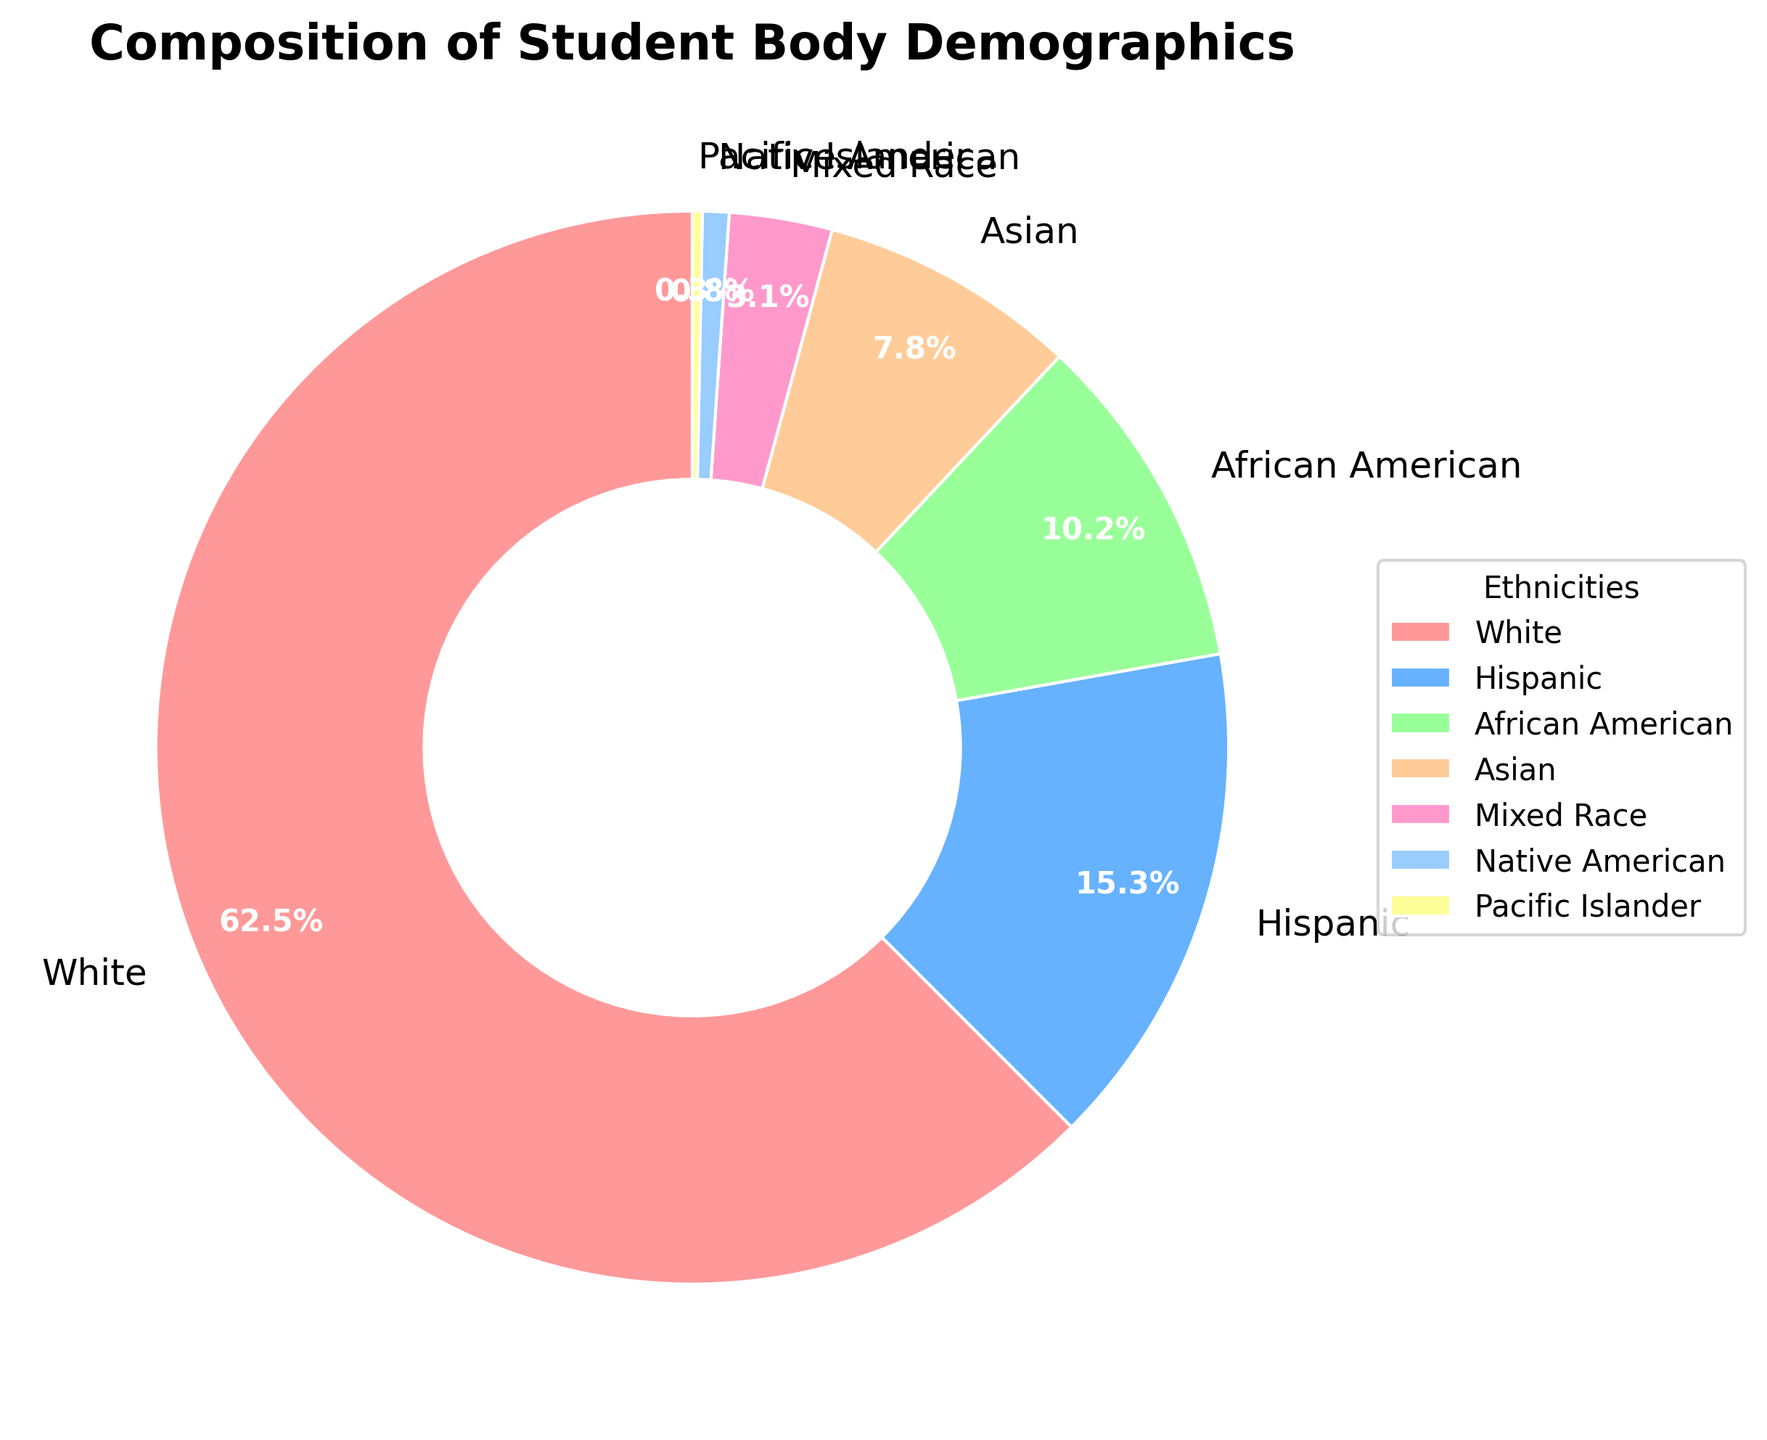What percentage of the student body is made up of White and Asian students combined? We look at the percentages for White and Asian students, which are 62.5% and 7.8% respectively. Adding these together gives 62.5 + 7.8 = 70.3%
Answer: 70.3% How much larger is the percentage of Hispanic students compared to Pacific Islander students? The percentage of Hispanic students is 15.3%, and the percentage of Pacific Islander students is 0.3%. Subtracting these values gives 15.3 - 0.3 = 15%
Answer: 15% Which ethnic group has the smallest representation in the student body? Examining the percentages, the smallest value is 0.3%, which corresponds to the Pacific Islander group
Answer: Pacific Islander What is the difference in percentage between African American and Native American students? The percentage for African American students is 10.2%, and for Native American students, it is 0.8%. Subtracting these gives 10.2 - 0.8 = 9.4%
Answer: 9.4% Which two ethnic groups together make up approximately the same percentage as the White students alone? The percentage for White students is 62.5%. Adding the percentages of Hispanic and African American students gives 15.3 + 10.2 = 25.5%, which is less. Adding Hispanic and Asian students gives 15.3 + 7.8 = 23.1%, again less. Adding Hispanic and Mixed Race gives 15.3 + 3.1 = 18.4%, less. However, adding Asian and African American students gives 7.8 + 10.2 = 18%, which is still less. Upon multiple trials, no single pair exactly matches 62.5%, but adding Hispanic, African American, and Asian provides 15.3 + 10.2 + 7.8 = 33.3%, still less than White percentage. Thus, Hispanic, African American, and Asian comes closest
Answer: Hispanic, African American, and Asian What is the combined percentage of Mixed Race and Native American students? The percentage for Mixed Race students is 3.1%, and for Native American students, it is 0.8%. Adding these gives 3.1 + 0.8 = 3.9%
Answer: 3.9% What percentage of the student body is non-White? The percentage for White students is 62.5%. To find the non-White percentage, we subtract this from 100%, giving 100 - 62.5 = 37.5%
Answer: 37.5% Among the ethnic groups listed, which one is closest in percentage to the Asian student percentage? The percentage for Asian students is 7.8%. The closest percentage is African American with 10.2%, which is more compared to other lesser values
Answer: African American How does the visual representation of the African American segment compare to the Mixed Race segment in terms of size? Visually, the segment for African American students is significantly larger than the segment for Mixed Race students. This matches the percentages 10.2% vs. 3.1% respectively
Answer: African American segment is larger What color is the section representing Hispanic students on the pie chart? The pie chart uses a gradient of colors, and for the Hispanic students' segment, the color is a shade of blue
Answer: Blue 